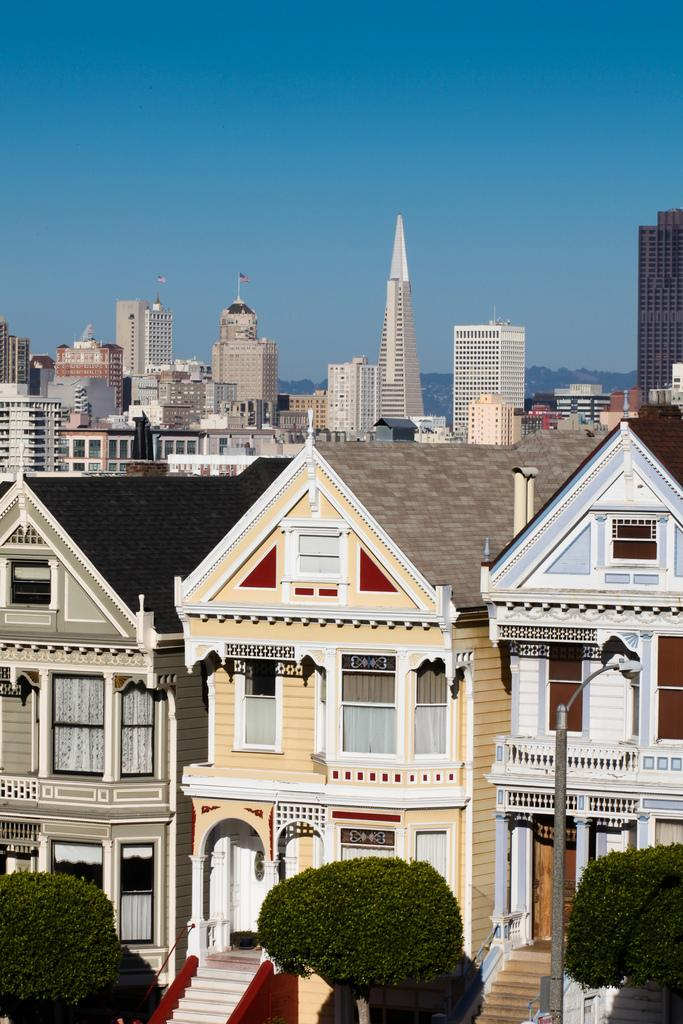How many trees are visible in the image? There are three trees in the image. What can be seen in the background of the image? There are buildings in the background of the image. What type of silk is being used to create the chairs in the image? There are no chairs present in the image, so it is not possible to determine what type of silk might be used. 